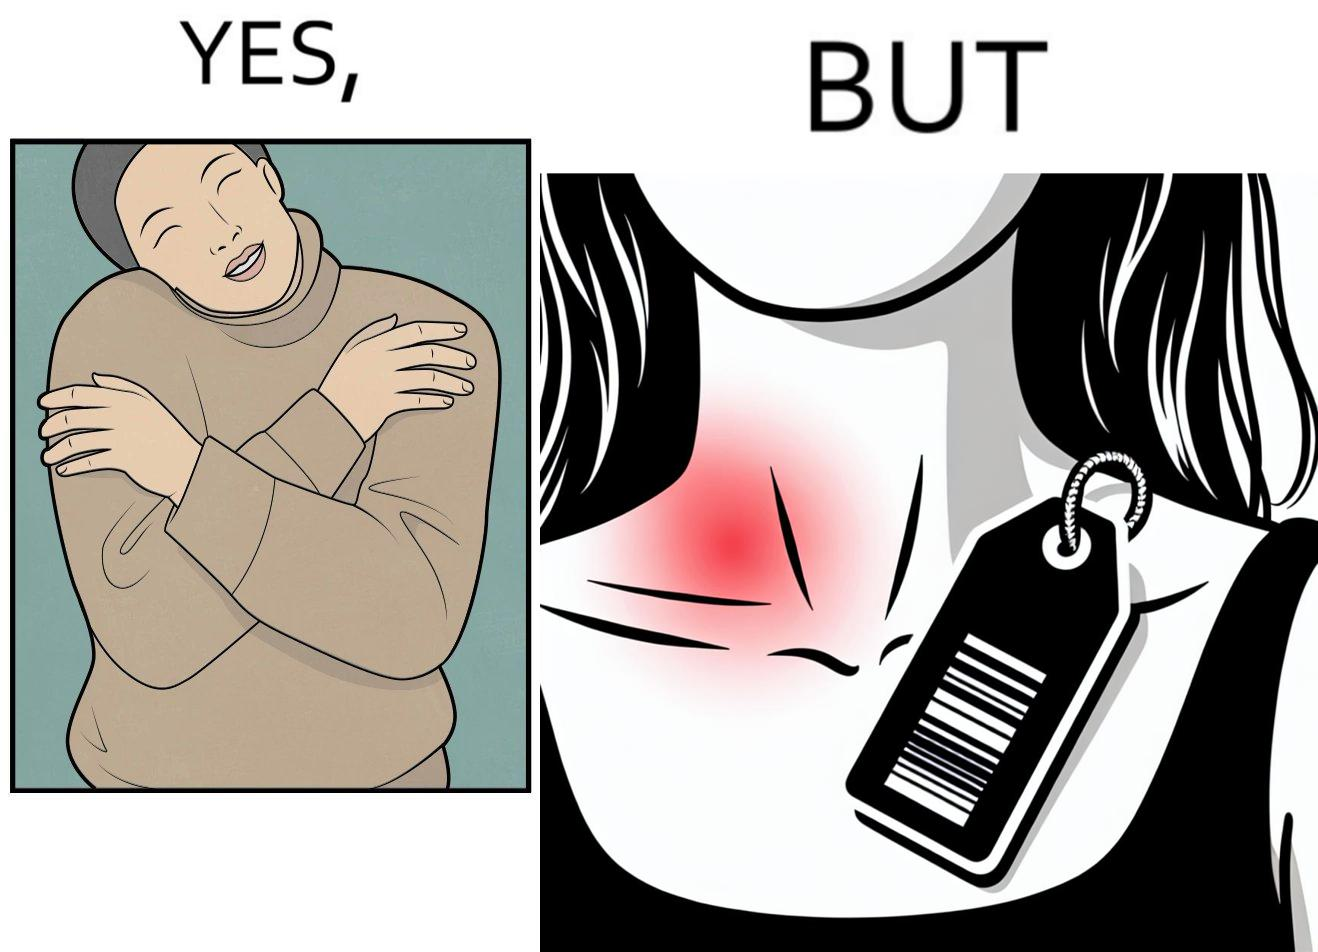What is shown in this image? The images are funny since it shows how even though sweaters and other clothings provide much comfort, a tiny manufacturers tag ends up causing the user a lot of discomfort due to constant scratching 